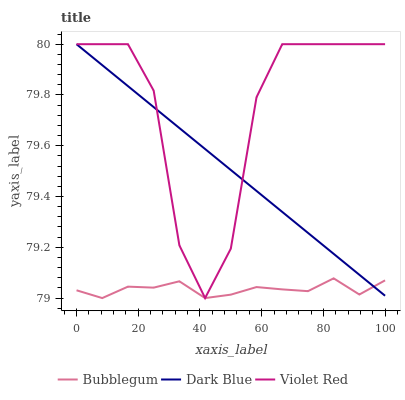Does Bubblegum have the minimum area under the curve?
Answer yes or no. Yes. Does Violet Red have the maximum area under the curve?
Answer yes or no. Yes. Does Violet Red have the minimum area under the curve?
Answer yes or no. No. Does Bubblegum have the maximum area under the curve?
Answer yes or no. No. Is Dark Blue the smoothest?
Answer yes or no. Yes. Is Violet Red the roughest?
Answer yes or no. Yes. Is Bubblegum the smoothest?
Answer yes or no. No. Is Bubblegum the roughest?
Answer yes or no. No. Does Bubblegum have the lowest value?
Answer yes or no. Yes. Does Violet Red have the lowest value?
Answer yes or no. No. Does Violet Red have the highest value?
Answer yes or no. Yes. Does Bubblegum have the highest value?
Answer yes or no. No. Is Bubblegum less than Violet Red?
Answer yes or no. Yes. Is Violet Red greater than Bubblegum?
Answer yes or no. Yes. Does Dark Blue intersect Bubblegum?
Answer yes or no. Yes. Is Dark Blue less than Bubblegum?
Answer yes or no. No. Is Dark Blue greater than Bubblegum?
Answer yes or no. No. Does Bubblegum intersect Violet Red?
Answer yes or no. No. 